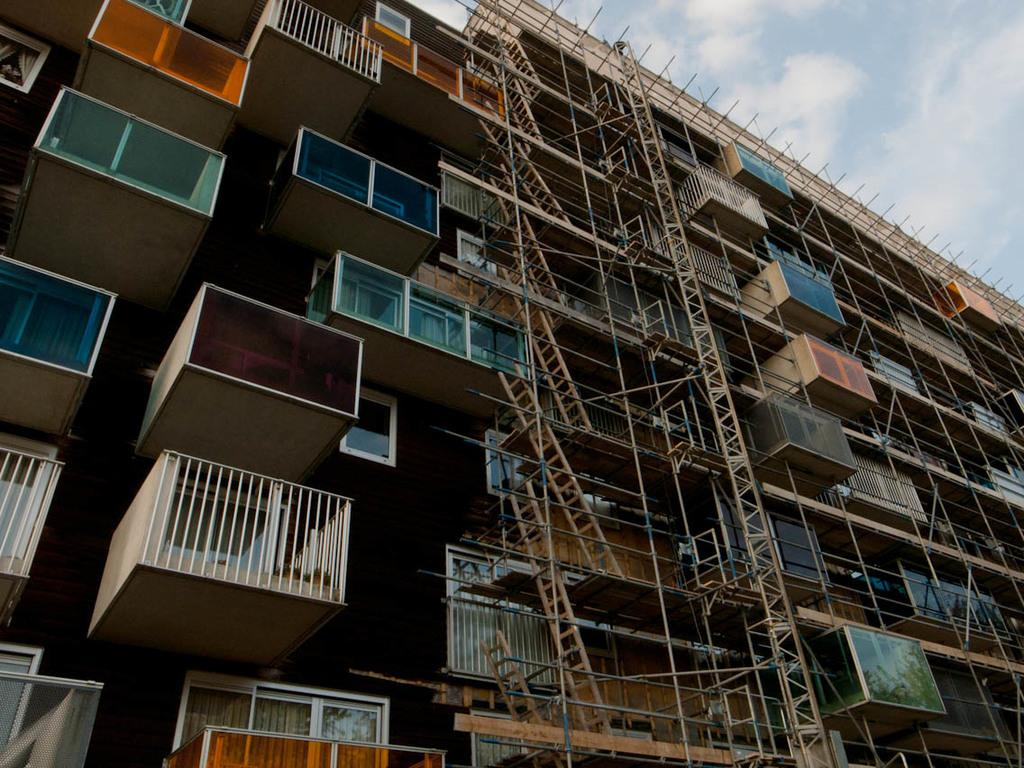What is the main subject of the image? The image shows a building under construction. What can be seen on the building in the image? There are rods and ladders visible in the image. What architectural features are present in the building? Windows and balconies are present in the image. What is visible in the sky in the top corner of the image? There are clouds in the sky in the top corner of the image. What type of celery can be seen growing on the balconies in the image? There is no celery present in the image; it shows a building under construction with windows and balconies. How many planes are parked on the balconies in the image? There are no planes present in the image; it shows a building under construction with windows and balconies. 